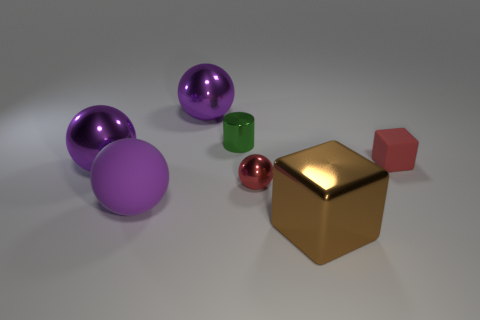How many purple spheres must be subtracted to get 1 purple spheres? 2 Subtract all gray cubes. How many purple balls are left? 3 Subtract all small spheres. How many spheres are left? 3 Add 3 big blue metal things. How many objects exist? 10 Subtract all red spheres. How many spheres are left? 3 Subtract all cyan balls. Subtract all red blocks. How many balls are left? 4 Subtract all balls. How many objects are left? 3 Add 6 large brown blocks. How many large brown blocks are left? 7 Add 5 blocks. How many blocks exist? 7 Subtract 0 green blocks. How many objects are left? 7 